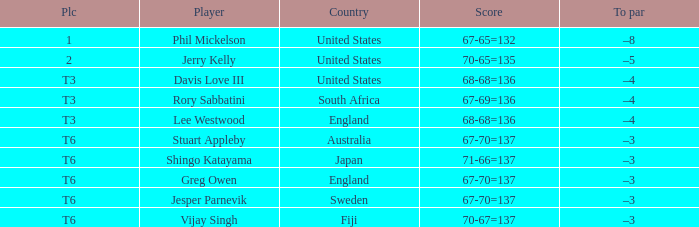What is the venue where the sum of 67-70=137 is associated with stuart appleby? T6. 